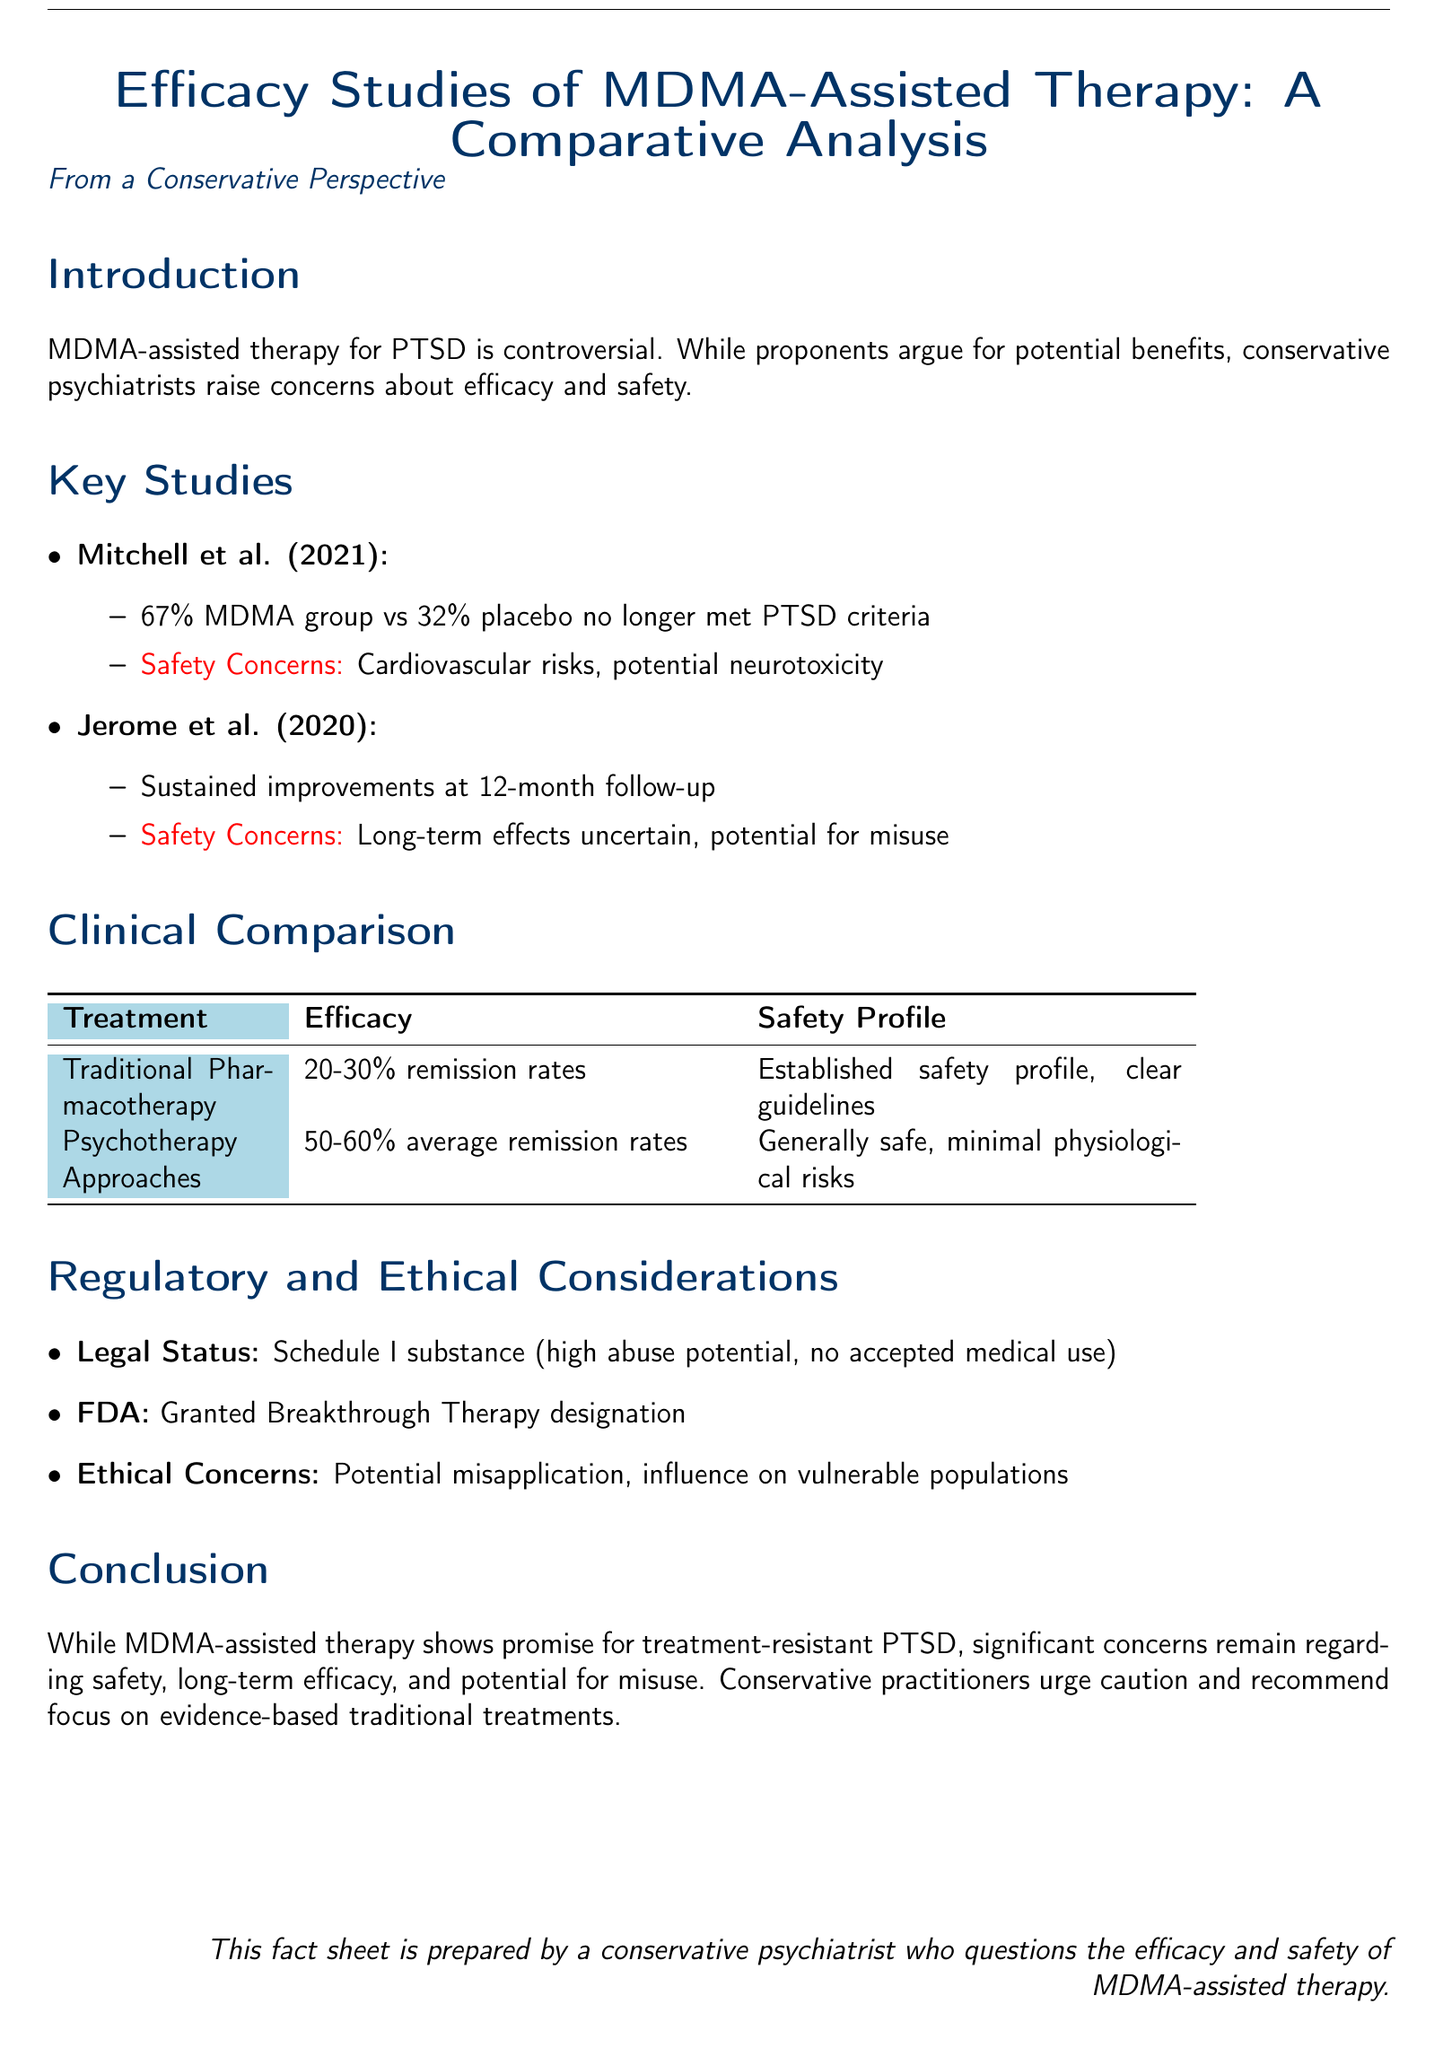What percentage of the MDMA group no longer met PTSD criteria according to Mitchell et al. (2021)? Mitchell et al. (2021) reported that 67% of the MDMA group no longer met PTSD criteria, indicating effectiveness.
Answer: 67% What is the primary safety concern mentioned in Jerome et al. (2020)? Jerome et al. (2020) raises concerns about the uncertain long-term effects and potential for misuse of MDMA-assisted therapy.
Answer: Long-term effects uncertain, potential for misuse What is the average remission rate for psychotherapy approaches? The document states that psychotherapy approaches have an average remission rate of 50-60%, indicating a relatively high level of efficacy.
Answer: 50-60% What designation did the FDA grant to MDMA-assisted therapy? The FDA granted Breakthrough Therapy designation to MDMA-assisted therapy, highlighting its potential for treatment-resistant PTSD.
Answer: Breakthrough Therapy designation What classification is MDMA under legal status? The document refers to MDMA as a Schedule I substance, suggesting significant regulatory restrictions due to abuse potential.
Answer: Schedule I substance What percentage of remission rates does traditional pharmacotherapy achieve? The text indicates that traditional pharmacotherapy has 20-30% remission rates, suggesting lower efficacy compared to other treatments.
Answer: 20-30% Which study reports sustained improvements at a 12-month follow-up? The study by Jerome et al. (2020) is specifically mentioned for reporting sustained improvements at a 12-month follow-up period.
Answer: Jerome et al. (2020) What are the established safety profiles associated with traditional pharmacotherapy? Traditional pharmacotherapy has an established safety profile with clear guidelines, reducing concerns about its use.
Answer: Established safety profile, clear guidelines What do conservative practitioners recommend focusing on? Conservative practitioners urge a focus on evidence-based traditional treatments due to concerns over the safety and efficacy of MDMA-assisted therapy.
Answer: Evidence-based traditional treatments 